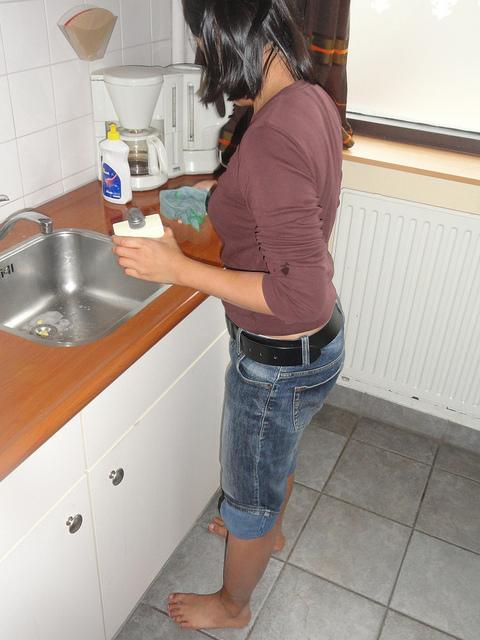What is this room most likely called? Please explain your reasoning. utility room. This is likely a room for utilities such as running water sinks. 